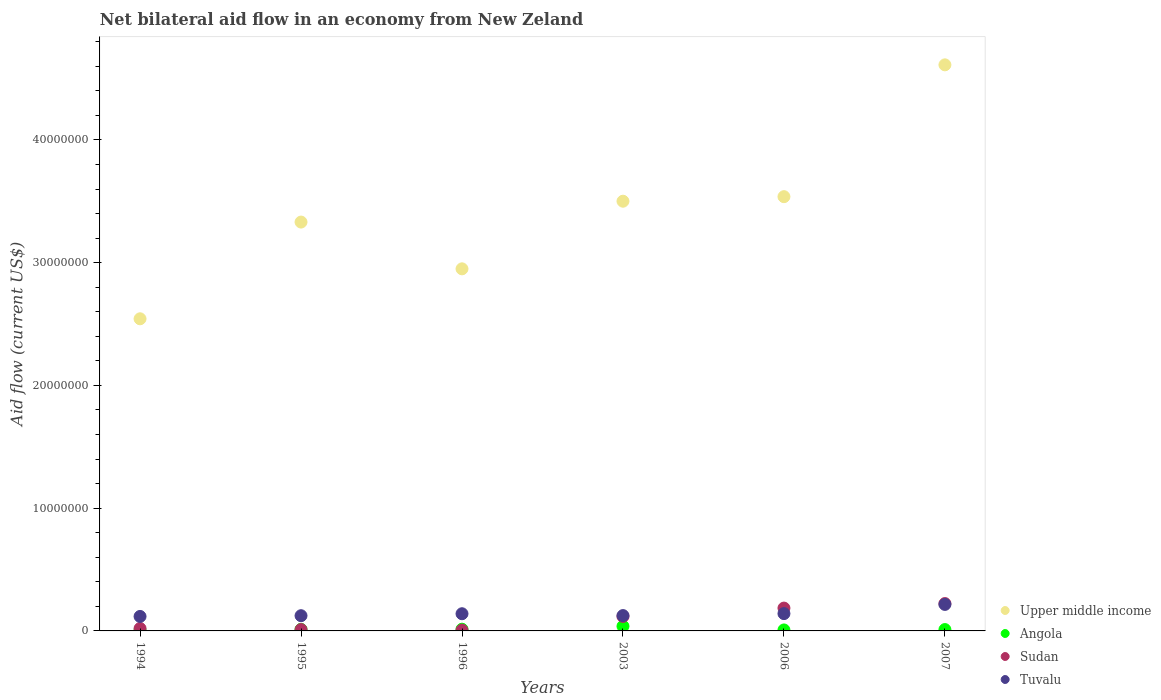Is the number of dotlines equal to the number of legend labels?
Ensure brevity in your answer.  Yes. What is the net bilateral aid flow in Upper middle income in 1994?
Your answer should be compact. 2.54e+07. Across all years, what is the maximum net bilateral aid flow in Sudan?
Ensure brevity in your answer.  2.23e+06. Across all years, what is the minimum net bilateral aid flow in Upper middle income?
Give a very brief answer. 2.54e+07. What is the total net bilateral aid flow in Tuvalu in the graph?
Provide a succinct answer. 8.64e+06. What is the difference between the net bilateral aid flow in Angola in 2003 and that in 2007?
Give a very brief answer. 2.70e+05. What is the difference between the net bilateral aid flow in Tuvalu in 1994 and the net bilateral aid flow in Sudan in 1995?
Give a very brief answer. 1.07e+06. What is the average net bilateral aid flow in Sudan per year?
Provide a succinct answer. 9.42e+05. In the year 2003, what is the difference between the net bilateral aid flow in Upper middle income and net bilateral aid flow in Sudan?
Keep it short and to the point. 3.38e+07. In how many years, is the net bilateral aid flow in Angola greater than 20000000 US$?
Offer a very short reply. 0. What is the ratio of the net bilateral aid flow in Upper middle income in 1996 to that in 2003?
Offer a terse response. 0.84. Is the net bilateral aid flow in Tuvalu in 1994 less than that in 1995?
Give a very brief answer. Yes. Is the difference between the net bilateral aid flow in Upper middle income in 1995 and 1996 greater than the difference between the net bilateral aid flow in Sudan in 1995 and 1996?
Make the answer very short. Yes. What is the difference between the highest and the second highest net bilateral aid flow in Sudan?
Make the answer very short. 3.70e+05. What is the difference between the highest and the lowest net bilateral aid flow in Sudan?
Give a very brief answer. 2.16e+06. In how many years, is the net bilateral aid flow in Upper middle income greater than the average net bilateral aid flow in Upper middle income taken over all years?
Give a very brief answer. 3. Is the sum of the net bilateral aid flow in Tuvalu in 1994 and 2006 greater than the maximum net bilateral aid flow in Upper middle income across all years?
Your answer should be compact. No. How many years are there in the graph?
Offer a very short reply. 6. Are the values on the major ticks of Y-axis written in scientific E-notation?
Provide a short and direct response. No. Where does the legend appear in the graph?
Your response must be concise. Bottom right. How many legend labels are there?
Your response must be concise. 4. What is the title of the graph?
Your answer should be very brief. Net bilateral aid flow in an economy from New Zeland. What is the label or title of the Y-axis?
Your answer should be very brief. Aid flow (current US$). What is the Aid flow (current US$) in Upper middle income in 1994?
Offer a very short reply. 2.54e+07. What is the Aid flow (current US$) of Angola in 1994?
Keep it short and to the point. 6.00e+04. What is the Aid flow (current US$) in Sudan in 1994?
Your answer should be very brief. 2.00e+05. What is the Aid flow (current US$) in Tuvalu in 1994?
Provide a succinct answer. 1.18e+06. What is the Aid flow (current US$) in Upper middle income in 1995?
Offer a very short reply. 3.33e+07. What is the Aid flow (current US$) in Angola in 1995?
Provide a succinct answer. 1.30e+05. What is the Aid flow (current US$) in Tuvalu in 1995?
Ensure brevity in your answer.  1.24e+06. What is the Aid flow (current US$) of Upper middle income in 1996?
Provide a short and direct response. 2.95e+07. What is the Aid flow (current US$) of Angola in 1996?
Ensure brevity in your answer.  1.40e+05. What is the Aid flow (current US$) of Tuvalu in 1996?
Provide a succinct answer. 1.40e+06. What is the Aid flow (current US$) in Upper middle income in 2003?
Your answer should be very brief. 3.50e+07. What is the Aid flow (current US$) in Angola in 2003?
Make the answer very short. 3.80e+05. What is the Aid flow (current US$) in Sudan in 2003?
Make the answer very short. 1.18e+06. What is the Aid flow (current US$) of Tuvalu in 2003?
Your response must be concise. 1.25e+06. What is the Aid flow (current US$) in Upper middle income in 2006?
Your response must be concise. 3.54e+07. What is the Aid flow (current US$) in Sudan in 2006?
Make the answer very short. 1.86e+06. What is the Aid flow (current US$) of Tuvalu in 2006?
Your answer should be compact. 1.41e+06. What is the Aid flow (current US$) in Upper middle income in 2007?
Provide a succinct answer. 4.61e+07. What is the Aid flow (current US$) in Sudan in 2007?
Offer a terse response. 2.23e+06. What is the Aid flow (current US$) in Tuvalu in 2007?
Keep it short and to the point. 2.16e+06. Across all years, what is the maximum Aid flow (current US$) in Upper middle income?
Make the answer very short. 4.61e+07. Across all years, what is the maximum Aid flow (current US$) of Sudan?
Offer a terse response. 2.23e+06. Across all years, what is the maximum Aid flow (current US$) in Tuvalu?
Offer a very short reply. 2.16e+06. Across all years, what is the minimum Aid flow (current US$) in Upper middle income?
Offer a very short reply. 2.54e+07. Across all years, what is the minimum Aid flow (current US$) in Sudan?
Ensure brevity in your answer.  7.00e+04. Across all years, what is the minimum Aid flow (current US$) of Tuvalu?
Your answer should be compact. 1.18e+06. What is the total Aid flow (current US$) in Upper middle income in the graph?
Keep it short and to the point. 2.05e+08. What is the total Aid flow (current US$) in Angola in the graph?
Give a very brief answer. 9.00e+05. What is the total Aid flow (current US$) in Sudan in the graph?
Your response must be concise. 5.65e+06. What is the total Aid flow (current US$) of Tuvalu in the graph?
Keep it short and to the point. 8.64e+06. What is the difference between the Aid flow (current US$) of Upper middle income in 1994 and that in 1995?
Your response must be concise. -7.88e+06. What is the difference between the Aid flow (current US$) of Tuvalu in 1994 and that in 1995?
Provide a succinct answer. -6.00e+04. What is the difference between the Aid flow (current US$) in Upper middle income in 1994 and that in 1996?
Your response must be concise. -4.07e+06. What is the difference between the Aid flow (current US$) in Tuvalu in 1994 and that in 1996?
Your response must be concise. -2.20e+05. What is the difference between the Aid flow (current US$) of Upper middle income in 1994 and that in 2003?
Provide a succinct answer. -9.58e+06. What is the difference between the Aid flow (current US$) of Angola in 1994 and that in 2003?
Ensure brevity in your answer.  -3.20e+05. What is the difference between the Aid flow (current US$) in Sudan in 1994 and that in 2003?
Provide a succinct answer. -9.80e+05. What is the difference between the Aid flow (current US$) in Upper middle income in 1994 and that in 2006?
Offer a very short reply. -9.95e+06. What is the difference between the Aid flow (current US$) in Angola in 1994 and that in 2006?
Your answer should be very brief. -2.00e+04. What is the difference between the Aid flow (current US$) in Sudan in 1994 and that in 2006?
Provide a short and direct response. -1.66e+06. What is the difference between the Aid flow (current US$) in Upper middle income in 1994 and that in 2007?
Your answer should be compact. -2.07e+07. What is the difference between the Aid flow (current US$) in Sudan in 1994 and that in 2007?
Your answer should be very brief. -2.03e+06. What is the difference between the Aid flow (current US$) in Tuvalu in 1994 and that in 2007?
Your response must be concise. -9.80e+05. What is the difference between the Aid flow (current US$) in Upper middle income in 1995 and that in 1996?
Offer a terse response. 3.81e+06. What is the difference between the Aid flow (current US$) of Upper middle income in 1995 and that in 2003?
Provide a succinct answer. -1.70e+06. What is the difference between the Aid flow (current US$) in Sudan in 1995 and that in 2003?
Ensure brevity in your answer.  -1.07e+06. What is the difference between the Aid flow (current US$) in Upper middle income in 1995 and that in 2006?
Offer a very short reply. -2.07e+06. What is the difference between the Aid flow (current US$) of Angola in 1995 and that in 2006?
Ensure brevity in your answer.  5.00e+04. What is the difference between the Aid flow (current US$) of Sudan in 1995 and that in 2006?
Provide a succinct answer. -1.75e+06. What is the difference between the Aid flow (current US$) in Upper middle income in 1995 and that in 2007?
Provide a succinct answer. -1.28e+07. What is the difference between the Aid flow (current US$) of Sudan in 1995 and that in 2007?
Provide a short and direct response. -2.12e+06. What is the difference between the Aid flow (current US$) in Tuvalu in 1995 and that in 2007?
Your response must be concise. -9.20e+05. What is the difference between the Aid flow (current US$) in Upper middle income in 1996 and that in 2003?
Make the answer very short. -5.51e+06. What is the difference between the Aid flow (current US$) in Angola in 1996 and that in 2003?
Your answer should be very brief. -2.40e+05. What is the difference between the Aid flow (current US$) in Sudan in 1996 and that in 2003?
Keep it short and to the point. -1.11e+06. What is the difference between the Aid flow (current US$) of Tuvalu in 1996 and that in 2003?
Offer a very short reply. 1.50e+05. What is the difference between the Aid flow (current US$) in Upper middle income in 1996 and that in 2006?
Keep it short and to the point. -5.88e+06. What is the difference between the Aid flow (current US$) of Angola in 1996 and that in 2006?
Give a very brief answer. 6.00e+04. What is the difference between the Aid flow (current US$) of Sudan in 1996 and that in 2006?
Your answer should be very brief. -1.79e+06. What is the difference between the Aid flow (current US$) of Upper middle income in 1996 and that in 2007?
Provide a succinct answer. -1.66e+07. What is the difference between the Aid flow (current US$) in Angola in 1996 and that in 2007?
Your answer should be very brief. 3.00e+04. What is the difference between the Aid flow (current US$) in Sudan in 1996 and that in 2007?
Your answer should be compact. -2.16e+06. What is the difference between the Aid flow (current US$) of Tuvalu in 1996 and that in 2007?
Provide a succinct answer. -7.60e+05. What is the difference between the Aid flow (current US$) of Upper middle income in 2003 and that in 2006?
Make the answer very short. -3.70e+05. What is the difference between the Aid flow (current US$) of Angola in 2003 and that in 2006?
Your response must be concise. 3.00e+05. What is the difference between the Aid flow (current US$) in Sudan in 2003 and that in 2006?
Your answer should be very brief. -6.80e+05. What is the difference between the Aid flow (current US$) of Upper middle income in 2003 and that in 2007?
Your answer should be very brief. -1.11e+07. What is the difference between the Aid flow (current US$) of Sudan in 2003 and that in 2007?
Offer a very short reply. -1.05e+06. What is the difference between the Aid flow (current US$) in Tuvalu in 2003 and that in 2007?
Provide a short and direct response. -9.10e+05. What is the difference between the Aid flow (current US$) in Upper middle income in 2006 and that in 2007?
Make the answer very short. -1.07e+07. What is the difference between the Aid flow (current US$) of Angola in 2006 and that in 2007?
Offer a terse response. -3.00e+04. What is the difference between the Aid flow (current US$) in Sudan in 2006 and that in 2007?
Make the answer very short. -3.70e+05. What is the difference between the Aid flow (current US$) of Tuvalu in 2006 and that in 2007?
Ensure brevity in your answer.  -7.50e+05. What is the difference between the Aid flow (current US$) of Upper middle income in 1994 and the Aid flow (current US$) of Angola in 1995?
Offer a very short reply. 2.53e+07. What is the difference between the Aid flow (current US$) of Upper middle income in 1994 and the Aid flow (current US$) of Sudan in 1995?
Your response must be concise. 2.53e+07. What is the difference between the Aid flow (current US$) of Upper middle income in 1994 and the Aid flow (current US$) of Tuvalu in 1995?
Make the answer very short. 2.42e+07. What is the difference between the Aid flow (current US$) of Angola in 1994 and the Aid flow (current US$) of Tuvalu in 1995?
Provide a short and direct response. -1.18e+06. What is the difference between the Aid flow (current US$) in Sudan in 1994 and the Aid flow (current US$) in Tuvalu in 1995?
Offer a terse response. -1.04e+06. What is the difference between the Aid flow (current US$) of Upper middle income in 1994 and the Aid flow (current US$) of Angola in 1996?
Your answer should be compact. 2.53e+07. What is the difference between the Aid flow (current US$) of Upper middle income in 1994 and the Aid flow (current US$) of Sudan in 1996?
Make the answer very short. 2.54e+07. What is the difference between the Aid flow (current US$) in Upper middle income in 1994 and the Aid flow (current US$) in Tuvalu in 1996?
Offer a terse response. 2.40e+07. What is the difference between the Aid flow (current US$) in Angola in 1994 and the Aid flow (current US$) in Tuvalu in 1996?
Offer a terse response. -1.34e+06. What is the difference between the Aid flow (current US$) of Sudan in 1994 and the Aid flow (current US$) of Tuvalu in 1996?
Your response must be concise. -1.20e+06. What is the difference between the Aid flow (current US$) of Upper middle income in 1994 and the Aid flow (current US$) of Angola in 2003?
Provide a succinct answer. 2.50e+07. What is the difference between the Aid flow (current US$) of Upper middle income in 1994 and the Aid flow (current US$) of Sudan in 2003?
Your answer should be very brief. 2.42e+07. What is the difference between the Aid flow (current US$) of Upper middle income in 1994 and the Aid flow (current US$) of Tuvalu in 2003?
Your response must be concise. 2.42e+07. What is the difference between the Aid flow (current US$) of Angola in 1994 and the Aid flow (current US$) of Sudan in 2003?
Ensure brevity in your answer.  -1.12e+06. What is the difference between the Aid flow (current US$) of Angola in 1994 and the Aid flow (current US$) of Tuvalu in 2003?
Make the answer very short. -1.19e+06. What is the difference between the Aid flow (current US$) of Sudan in 1994 and the Aid flow (current US$) of Tuvalu in 2003?
Offer a very short reply. -1.05e+06. What is the difference between the Aid flow (current US$) in Upper middle income in 1994 and the Aid flow (current US$) in Angola in 2006?
Provide a short and direct response. 2.54e+07. What is the difference between the Aid flow (current US$) of Upper middle income in 1994 and the Aid flow (current US$) of Sudan in 2006?
Ensure brevity in your answer.  2.36e+07. What is the difference between the Aid flow (current US$) in Upper middle income in 1994 and the Aid flow (current US$) in Tuvalu in 2006?
Provide a succinct answer. 2.40e+07. What is the difference between the Aid flow (current US$) of Angola in 1994 and the Aid flow (current US$) of Sudan in 2006?
Provide a succinct answer. -1.80e+06. What is the difference between the Aid flow (current US$) in Angola in 1994 and the Aid flow (current US$) in Tuvalu in 2006?
Give a very brief answer. -1.35e+06. What is the difference between the Aid flow (current US$) of Sudan in 1994 and the Aid flow (current US$) of Tuvalu in 2006?
Your response must be concise. -1.21e+06. What is the difference between the Aid flow (current US$) in Upper middle income in 1994 and the Aid flow (current US$) in Angola in 2007?
Provide a succinct answer. 2.53e+07. What is the difference between the Aid flow (current US$) in Upper middle income in 1994 and the Aid flow (current US$) in Sudan in 2007?
Your answer should be very brief. 2.32e+07. What is the difference between the Aid flow (current US$) of Upper middle income in 1994 and the Aid flow (current US$) of Tuvalu in 2007?
Offer a terse response. 2.33e+07. What is the difference between the Aid flow (current US$) in Angola in 1994 and the Aid flow (current US$) in Sudan in 2007?
Your answer should be very brief. -2.17e+06. What is the difference between the Aid flow (current US$) in Angola in 1994 and the Aid flow (current US$) in Tuvalu in 2007?
Your answer should be compact. -2.10e+06. What is the difference between the Aid flow (current US$) in Sudan in 1994 and the Aid flow (current US$) in Tuvalu in 2007?
Your response must be concise. -1.96e+06. What is the difference between the Aid flow (current US$) of Upper middle income in 1995 and the Aid flow (current US$) of Angola in 1996?
Keep it short and to the point. 3.32e+07. What is the difference between the Aid flow (current US$) of Upper middle income in 1995 and the Aid flow (current US$) of Sudan in 1996?
Ensure brevity in your answer.  3.32e+07. What is the difference between the Aid flow (current US$) in Upper middle income in 1995 and the Aid flow (current US$) in Tuvalu in 1996?
Provide a short and direct response. 3.19e+07. What is the difference between the Aid flow (current US$) in Angola in 1995 and the Aid flow (current US$) in Sudan in 1996?
Your answer should be very brief. 6.00e+04. What is the difference between the Aid flow (current US$) of Angola in 1995 and the Aid flow (current US$) of Tuvalu in 1996?
Your answer should be compact. -1.27e+06. What is the difference between the Aid flow (current US$) of Sudan in 1995 and the Aid flow (current US$) of Tuvalu in 1996?
Give a very brief answer. -1.29e+06. What is the difference between the Aid flow (current US$) of Upper middle income in 1995 and the Aid flow (current US$) of Angola in 2003?
Your response must be concise. 3.29e+07. What is the difference between the Aid flow (current US$) of Upper middle income in 1995 and the Aid flow (current US$) of Sudan in 2003?
Offer a very short reply. 3.21e+07. What is the difference between the Aid flow (current US$) of Upper middle income in 1995 and the Aid flow (current US$) of Tuvalu in 2003?
Ensure brevity in your answer.  3.21e+07. What is the difference between the Aid flow (current US$) of Angola in 1995 and the Aid flow (current US$) of Sudan in 2003?
Your answer should be compact. -1.05e+06. What is the difference between the Aid flow (current US$) of Angola in 1995 and the Aid flow (current US$) of Tuvalu in 2003?
Offer a terse response. -1.12e+06. What is the difference between the Aid flow (current US$) of Sudan in 1995 and the Aid flow (current US$) of Tuvalu in 2003?
Offer a terse response. -1.14e+06. What is the difference between the Aid flow (current US$) of Upper middle income in 1995 and the Aid flow (current US$) of Angola in 2006?
Make the answer very short. 3.32e+07. What is the difference between the Aid flow (current US$) in Upper middle income in 1995 and the Aid flow (current US$) in Sudan in 2006?
Offer a terse response. 3.14e+07. What is the difference between the Aid flow (current US$) of Upper middle income in 1995 and the Aid flow (current US$) of Tuvalu in 2006?
Offer a very short reply. 3.19e+07. What is the difference between the Aid flow (current US$) of Angola in 1995 and the Aid flow (current US$) of Sudan in 2006?
Offer a terse response. -1.73e+06. What is the difference between the Aid flow (current US$) of Angola in 1995 and the Aid flow (current US$) of Tuvalu in 2006?
Make the answer very short. -1.28e+06. What is the difference between the Aid flow (current US$) in Sudan in 1995 and the Aid flow (current US$) in Tuvalu in 2006?
Ensure brevity in your answer.  -1.30e+06. What is the difference between the Aid flow (current US$) of Upper middle income in 1995 and the Aid flow (current US$) of Angola in 2007?
Give a very brief answer. 3.32e+07. What is the difference between the Aid flow (current US$) of Upper middle income in 1995 and the Aid flow (current US$) of Sudan in 2007?
Keep it short and to the point. 3.11e+07. What is the difference between the Aid flow (current US$) of Upper middle income in 1995 and the Aid flow (current US$) of Tuvalu in 2007?
Make the answer very short. 3.12e+07. What is the difference between the Aid flow (current US$) in Angola in 1995 and the Aid flow (current US$) in Sudan in 2007?
Offer a very short reply. -2.10e+06. What is the difference between the Aid flow (current US$) of Angola in 1995 and the Aid flow (current US$) of Tuvalu in 2007?
Offer a very short reply. -2.03e+06. What is the difference between the Aid flow (current US$) of Sudan in 1995 and the Aid flow (current US$) of Tuvalu in 2007?
Provide a short and direct response. -2.05e+06. What is the difference between the Aid flow (current US$) in Upper middle income in 1996 and the Aid flow (current US$) in Angola in 2003?
Offer a very short reply. 2.91e+07. What is the difference between the Aid flow (current US$) in Upper middle income in 1996 and the Aid flow (current US$) in Sudan in 2003?
Your response must be concise. 2.83e+07. What is the difference between the Aid flow (current US$) in Upper middle income in 1996 and the Aid flow (current US$) in Tuvalu in 2003?
Your answer should be compact. 2.82e+07. What is the difference between the Aid flow (current US$) in Angola in 1996 and the Aid flow (current US$) in Sudan in 2003?
Keep it short and to the point. -1.04e+06. What is the difference between the Aid flow (current US$) in Angola in 1996 and the Aid flow (current US$) in Tuvalu in 2003?
Provide a short and direct response. -1.11e+06. What is the difference between the Aid flow (current US$) of Sudan in 1996 and the Aid flow (current US$) of Tuvalu in 2003?
Your answer should be compact. -1.18e+06. What is the difference between the Aid flow (current US$) of Upper middle income in 1996 and the Aid flow (current US$) of Angola in 2006?
Provide a succinct answer. 2.94e+07. What is the difference between the Aid flow (current US$) in Upper middle income in 1996 and the Aid flow (current US$) in Sudan in 2006?
Offer a very short reply. 2.76e+07. What is the difference between the Aid flow (current US$) of Upper middle income in 1996 and the Aid flow (current US$) of Tuvalu in 2006?
Ensure brevity in your answer.  2.81e+07. What is the difference between the Aid flow (current US$) in Angola in 1996 and the Aid flow (current US$) in Sudan in 2006?
Offer a very short reply. -1.72e+06. What is the difference between the Aid flow (current US$) in Angola in 1996 and the Aid flow (current US$) in Tuvalu in 2006?
Your answer should be compact. -1.27e+06. What is the difference between the Aid flow (current US$) in Sudan in 1996 and the Aid flow (current US$) in Tuvalu in 2006?
Provide a short and direct response. -1.34e+06. What is the difference between the Aid flow (current US$) of Upper middle income in 1996 and the Aid flow (current US$) of Angola in 2007?
Offer a very short reply. 2.94e+07. What is the difference between the Aid flow (current US$) in Upper middle income in 1996 and the Aid flow (current US$) in Sudan in 2007?
Offer a terse response. 2.73e+07. What is the difference between the Aid flow (current US$) of Upper middle income in 1996 and the Aid flow (current US$) of Tuvalu in 2007?
Give a very brief answer. 2.73e+07. What is the difference between the Aid flow (current US$) of Angola in 1996 and the Aid flow (current US$) of Sudan in 2007?
Offer a terse response. -2.09e+06. What is the difference between the Aid flow (current US$) of Angola in 1996 and the Aid flow (current US$) of Tuvalu in 2007?
Ensure brevity in your answer.  -2.02e+06. What is the difference between the Aid flow (current US$) in Sudan in 1996 and the Aid flow (current US$) in Tuvalu in 2007?
Give a very brief answer. -2.09e+06. What is the difference between the Aid flow (current US$) of Upper middle income in 2003 and the Aid flow (current US$) of Angola in 2006?
Keep it short and to the point. 3.49e+07. What is the difference between the Aid flow (current US$) of Upper middle income in 2003 and the Aid flow (current US$) of Sudan in 2006?
Make the answer very short. 3.32e+07. What is the difference between the Aid flow (current US$) of Upper middle income in 2003 and the Aid flow (current US$) of Tuvalu in 2006?
Your answer should be compact. 3.36e+07. What is the difference between the Aid flow (current US$) in Angola in 2003 and the Aid flow (current US$) in Sudan in 2006?
Give a very brief answer. -1.48e+06. What is the difference between the Aid flow (current US$) in Angola in 2003 and the Aid flow (current US$) in Tuvalu in 2006?
Offer a terse response. -1.03e+06. What is the difference between the Aid flow (current US$) of Upper middle income in 2003 and the Aid flow (current US$) of Angola in 2007?
Offer a terse response. 3.49e+07. What is the difference between the Aid flow (current US$) of Upper middle income in 2003 and the Aid flow (current US$) of Sudan in 2007?
Your answer should be very brief. 3.28e+07. What is the difference between the Aid flow (current US$) of Upper middle income in 2003 and the Aid flow (current US$) of Tuvalu in 2007?
Ensure brevity in your answer.  3.28e+07. What is the difference between the Aid flow (current US$) of Angola in 2003 and the Aid flow (current US$) of Sudan in 2007?
Give a very brief answer. -1.85e+06. What is the difference between the Aid flow (current US$) in Angola in 2003 and the Aid flow (current US$) in Tuvalu in 2007?
Your answer should be very brief. -1.78e+06. What is the difference between the Aid flow (current US$) of Sudan in 2003 and the Aid flow (current US$) of Tuvalu in 2007?
Provide a succinct answer. -9.80e+05. What is the difference between the Aid flow (current US$) of Upper middle income in 2006 and the Aid flow (current US$) of Angola in 2007?
Your response must be concise. 3.53e+07. What is the difference between the Aid flow (current US$) in Upper middle income in 2006 and the Aid flow (current US$) in Sudan in 2007?
Keep it short and to the point. 3.32e+07. What is the difference between the Aid flow (current US$) in Upper middle income in 2006 and the Aid flow (current US$) in Tuvalu in 2007?
Offer a terse response. 3.32e+07. What is the difference between the Aid flow (current US$) in Angola in 2006 and the Aid flow (current US$) in Sudan in 2007?
Ensure brevity in your answer.  -2.15e+06. What is the difference between the Aid flow (current US$) in Angola in 2006 and the Aid flow (current US$) in Tuvalu in 2007?
Keep it short and to the point. -2.08e+06. What is the average Aid flow (current US$) of Upper middle income per year?
Provide a short and direct response. 3.41e+07. What is the average Aid flow (current US$) of Sudan per year?
Your answer should be very brief. 9.42e+05. What is the average Aid flow (current US$) in Tuvalu per year?
Keep it short and to the point. 1.44e+06. In the year 1994, what is the difference between the Aid flow (current US$) of Upper middle income and Aid flow (current US$) of Angola?
Keep it short and to the point. 2.54e+07. In the year 1994, what is the difference between the Aid flow (current US$) of Upper middle income and Aid flow (current US$) of Sudan?
Offer a very short reply. 2.52e+07. In the year 1994, what is the difference between the Aid flow (current US$) of Upper middle income and Aid flow (current US$) of Tuvalu?
Ensure brevity in your answer.  2.42e+07. In the year 1994, what is the difference between the Aid flow (current US$) in Angola and Aid flow (current US$) in Tuvalu?
Provide a short and direct response. -1.12e+06. In the year 1994, what is the difference between the Aid flow (current US$) of Sudan and Aid flow (current US$) of Tuvalu?
Keep it short and to the point. -9.80e+05. In the year 1995, what is the difference between the Aid flow (current US$) of Upper middle income and Aid flow (current US$) of Angola?
Provide a succinct answer. 3.32e+07. In the year 1995, what is the difference between the Aid flow (current US$) of Upper middle income and Aid flow (current US$) of Sudan?
Your answer should be very brief. 3.32e+07. In the year 1995, what is the difference between the Aid flow (current US$) of Upper middle income and Aid flow (current US$) of Tuvalu?
Give a very brief answer. 3.21e+07. In the year 1995, what is the difference between the Aid flow (current US$) of Angola and Aid flow (current US$) of Tuvalu?
Provide a short and direct response. -1.11e+06. In the year 1995, what is the difference between the Aid flow (current US$) of Sudan and Aid flow (current US$) of Tuvalu?
Your response must be concise. -1.13e+06. In the year 1996, what is the difference between the Aid flow (current US$) in Upper middle income and Aid flow (current US$) in Angola?
Ensure brevity in your answer.  2.94e+07. In the year 1996, what is the difference between the Aid flow (current US$) of Upper middle income and Aid flow (current US$) of Sudan?
Provide a short and direct response. 2.94e+07. In the year 1996, what is the difference between the Aid flow (current US$) in Upper middle income and Aid flow (current US$) in Tuvalu?
Provide a short and direct response. 2.81e+07. In the year 1996, what is the difference between the Aid flow (current US$) of Angola and Aid flow (current US$) of Tuvalu?
Provide a short and direct response. -1.26e+06. In the year 1996, what is the difference between the Aid flow (current US$) of Sudan and Aid flow (current US$) of Tuvalu?
Offer a terse response. -1.33e+06. In the year 2003, what is the difference between the Aid flow (current US$) of Upper middle income and Aid flow (current US$) of Angola?
Your answer should be very brief. 3.46e+07. In the year 2003, what is the difference between the Aid flow (current US$) in Upper middle income and Aid flow (current US$) in Sudan?
Your answer should be very brief. 3.38e+07. In the year 2003, what is the difference between the Aid flow (current US$) of Upper middle income and Aid flow (current US$) of Tuvalu?
Offer a terse response. 3.38e+07. In the year 2003, what is the difference between the Aid flow (current US$) in Angola and Aid flow (current US$) in Sudan?
Keep it short and to the point. -8.00e+05. In the year 2003, what is the difference between the Aid flow (current US$) of Angola and Aid flow (current US$) of Tuvalu?
Offer a terse response. -8.70e+05. In the year 2003, what is the difference between the Aid flow (current US$) in Sudan and Aid flow (current US$) in Tuvalu?
Your answer should be compact. -7.00e+04. In the year 2006, what is the difference between the Aid flow (current US$) of Upper middle income and Aid flow (current US$) of Angola?
Keep it short and to the point. 3.53e+07. In the year 2006, what is the difference between the Aid flow (current US$) in Upper middle income and Aid flow (current US$) in Sudan?
Offer a very short reply. 3.35e+07. In the year 2006, what is the difference between the Aid flow (current US$) in Upper middle income and Aid flow (current US$) in Tuvalu?
Ensure brevity in your answer.  3.40e+07. In the year 2006, what is the difference between the Aid flow (current US$) of Angola and Aid flow (current US$) of Sudan?
Offer a very short reply. -1.78e+06. In the year 2006, what is the difference between the Aid flow (current US$) of Angola and Aid flow (current US$) of Tuvalu?
Give a very brief answer. -1.33e+06. In the year 2007, what is the difference between the Aid flow (current US$) in Upper middle income and Aid flow (current US$) in Angola?
Make the answer very short. 4.60e+07. In the year 2007, what is the difference between the Aid flow (current US$) of Upper middle income and Aid flow (current US$) of Sudan?
Ensure brevity in your answer.  4.39e+07. In the year 2007, what is the difference between the Aid flow (current US$) in Upper middle income and Aid flow (current US$) in Tuvalu?
Offer a very short reply. 4.40e+07. In the year 2007, what is the difference between the Aid flow (current US$) of Angola and Aid flow (current US$) of Sudan?
Your answer should be very brief. -2.12e+06. In the year 2007, what is the difference between the Aid flow (current US$) in Angola and Aid flow (current US$) in Tuvalu?
Ensure brevity in your answer.  -2.05e+06. What is the ratio of the Aid flow (current US$) in Upper middle income in 1994 to that in 1995?
Keep it short and to the point. 0.76. What is the ratio of the Aid flow (current US$) of Angola in 1994 to that in 1995?
Ensure brevity in your answer.  0.46. What is the ratio of the Aid flow (current US$) in Sudan in 1994 to that in 1995?
Your answer should be compact. 1.82. What is the ratio of the Aid flow (current US$) of Tuvalu in 1994 to that in 1995?
Give a very brief answer. 0.95. What is the ratio of the Aid flow (current US$) of Upper middle income in 1994 to that in 1996?
Give a very brief answer. 0.86. What is the ratio of the Aid flow (current US$) of Angola in 1994 to that in 1996?
Your response must be concise. 0.43. What is the ratio of the Aid flow (current US$) of Sudan in 1994 to that in 1996?
Offer a terse response. 2.86. What is the ratio of the Aid flow (current US$) of Tuvalu in 1994 to that in 1996?
Your answer should be compact. 0.84. What is the ratio of the Aid flow (current US$) in Upper middle income in 1994 to that in 2003?
Offer a terse response. 0.73. What is the ratio of the Aid flow (current US$) of Angola in 1994 to that in 2003?
Offer a terse response. 0.16. What is the ratio of the Aid flow (current US$) of Sudan in 1994 to that in 2003?
Keep it short and to the point. 0.17. What is the ratio of the Aid flow (current US$) of Tuvalu in 1994 to that in 2003?
Ensure brevity in your answer.  0.94. What is the ratio of the Aid flow (current US$) of Upper middle income in 1994 to that in 2006?
Your response must be concise. 0.72. What is the ratio of the Aid flow (current US$) of Angola in 1994 to that in 2006?
Offer a very short reply. 0.75. What is the ratio of the Aid flow (current US$) of Sudan in 1994 to that in 2006?
Your answer should be very brief. 0.11. What is the ratio of the Aid flow (current US$) of Tuvalu in 1994 to that in 2006?
Your answer should be very brief. 0.84. What is the ratio of the Aid flow (current US$) in Upper middle income in 1994 to that in 2007?
Keep it short and to the point. 0.55. What is the ratio of the Aid flow (current US$) in Angola in 1994 to that in 2007?
Provide a short and direct response. 0.55. What is the ratio of the Aid flow (current US$) in Sudan in 1994 to that in 2007?
Give a very brief answer. 0.09. What is the ratio of the Aid flow (current US$) of Tuvalu in 1994 to that in 2007?
Your response must be concise. 0.55. What is the ratio of the Aid flow (current US$) in Upper middle income in 1995 to that in 1996?
Ensure brevity in your answer.  1.13. What is the ratio of the Aid flow (current US$) of Sudan in 1995 to that in 1996?
Offer a very short reply. 1.57. What is the ratio of the Aid flow (current US$) in Tuvalu in 1995 to that in 1996?
Offer a very short reply. 0.89. What is the ratio of the Aid flow (current US$) in Upper middle income in 1995 to that in 2003?
Offer a very short reply. 0.95. What is the ratio of the Aid flow (current US$) in Angola in 1995 to that in 2003?
Provide a short and direct response. 0.34. What is the ratio of the Aid flow (current US$) in Sudan in 1995 to that in 2003?
Give a very brief answer. 0.09. What is the ratio of the Aid flow (current US$) in Upper middle income in 1995 to that in 2006?
Your answer should be compact. 0.94. What is the ratio of the Aid flow (current US$) of Angola in 1995 to that in 2006?
Keep it short and to the point. 1.62. What is the ratio of the Aid flow (current US$) of Sudan in 1995 to that in 2006?
Your response must be concise. 0.06. What is the ratio of the Aid flow (current US$) of Tuvalu in 1995 to that in 2006?
Make the answer very short. 0.88. What is the ratio of the Aid flow (current US$) of Upper middle income in 1995 to that in 2007?
Provide a succinct answer. 0.72. What is the ratio of the Aid flow (current US$) in Angola in 1995 to that in 2007?
Your answer should be very brief. 1.18. What is the ratio of the Aid flow (current US$) in Sudan in 1995 to that in 2007?
Offer a very short reply. 0.05. What is the ratio of the Aid flow (current US$) in Tuvalu in 1995 to that in 2007?
Ensure brevity in your answer.  0.57. What is the ratio of the Aid flow (current US$) of Upper middle income in 1996 to that in 2003?
Ensure brevity in your answer.  0.84. What is the ratio of the Aid flow (current US$) in Angola in 1996 to that in 2003?
Provide a short and direct response. 0.37. What is the ratio of the Aid flow (current US$) of Sudan in 1996 to that in 2003?
Your answer should be compact. 0.06. What is the ratio of the Aid flow (current US$) of Tuvalu in 1996 to that in 2003?
Your answer should be compact. 1.12. What is the ratio of the Aid flow (current US$) of Upper middle income in 1996 to that in 2006?
Provide a short and direct response. 0.83. What is the ratio of the Aid flow (current US$) of Sudan in 1996 to that in 2006?
Your answer should be very brief. 0.04. What is the ratio of the Aid flow (current US$) of Tuvalu in 1996 to that in 2006?
Your response must be concise. 0.99. What is the ratio of the Aid flow (current US$) of Upper middle income in 1996 to that in 2007?
Ensure brevity in your answer.  0.64. What is the ratio of the Aid flow (current US$) of Angola in 1996 to that in 2007?
Your answer should be compact. 1.27. What is the ratio of the Aid flow (current US$) of Sudan in 1996 to that in 2007?
Your answer should be compact. 0.03. What is the ratio of the Aid flow (current US$) of Tuvalu in 1996 to that in 2007?
Provide a short and direct response. 0.65. What is the ratio of the Aid flow (current US$) in Upper middle income in 2003 to that in 2006?
Offer a very short reply. 0.99. What is the ratio of the Aid flow (current US$) in Angola in 2003 to that in 2006?
Your answer should be compact. 4.75. What is the ratio of the Aid flow (current US$) of Sudan in 2003 to that in 2006?
Make the answer very short. 0.63. What is the ratio of the Aid flow (current US$) in Tuvalu in 2003 to that in 2006?
Give a very brief answer. 0.89. What is the ratio of the Aid flow (current US$) of Upper middle income in 2003 to that in 2007?
Your response must be concise. 0.76. What is the ratio of the Aid flow (current US$) of Angola in 2003 to that in 2007?
Your response must be concise. 3.45. What is the ratio of the Aid flow (current US$) in Sudan in 2003 to that in 2007?
Offer a terse response. 0.53. What is the ratio of the Aid flow (current US$) in Tuvalu in 2003 to that in 2007?
Your answer should be very brief. 0.58. What is the ratio of the Aid flow (current US$) in Upper middle income in 2006 to that in 2007?
Give a very brief answer. 0.77. What is the ratio of the Aid flow (current US$) in Angola in 2006 to that in 2007?
Your answer should be compact. 0.73. What is the ratio of the Aid flow (current US$) of Sudan in 2006 to that in 2007?
Give a very brief answer. 0.83. What is the ratio of the Aid flow (current US$) of Tuvalu in 2006 to that in 2007?
Your answer should be very brief. 0.65. What is the difference between the highest and the second highest Aid flow (current US$) of Upper middle income?
Offer a very short reply. 1.07e+07. What is the difference between the highest and the second highest Aid flow (current US$) in Tuvalu?
Ensure brevity in your answer.  7.50e+05. What is the difference between the highest and the lowest Aid flow (current US$) in Upper middle income?
Offer a terse response. 2.07e+07. What is the difference between the highest and the lowest Aid flow (current US$) of Angola?
Make the answer very short. 3.20e+05. What is the difference between the highest and the lowest Aid flow (current US$) in Sudan?
Provide a succinct answer. 2.16e+06. What is the difference between the highest and the lowest Aid flow (current US$) in Tuvalu?
Provide a succinct answer. 9.80e+05. 